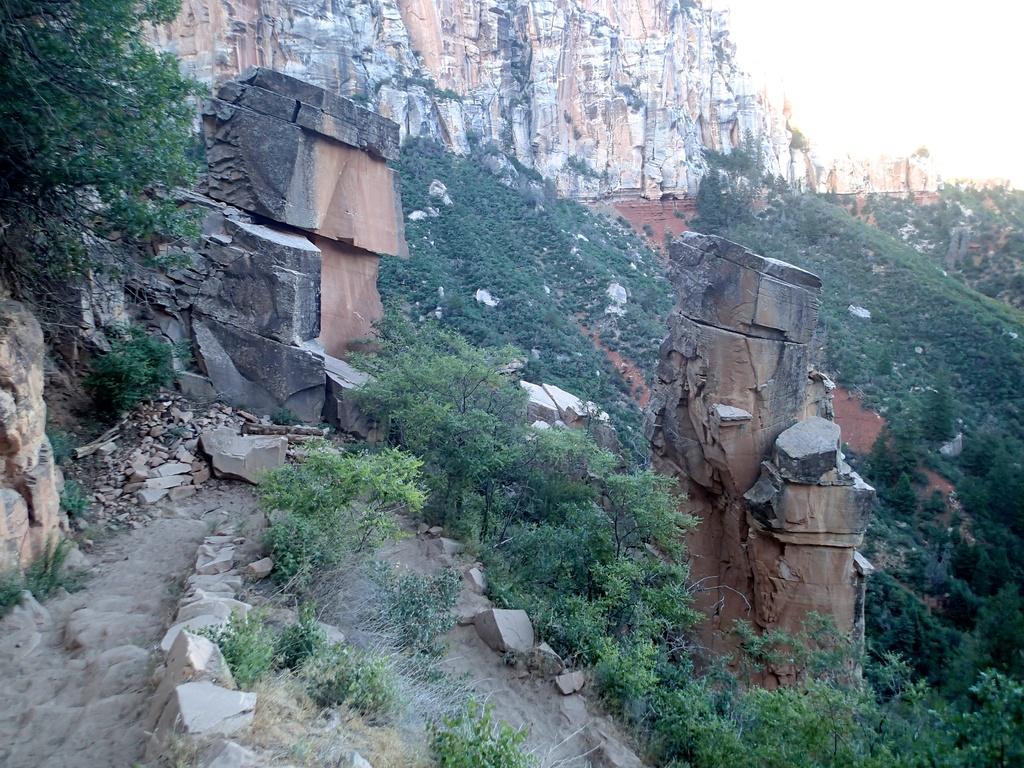How would you summarize this image in a sentence or two? In the image there are many trees and stones on the ground. And also there are rock hills in the background. 